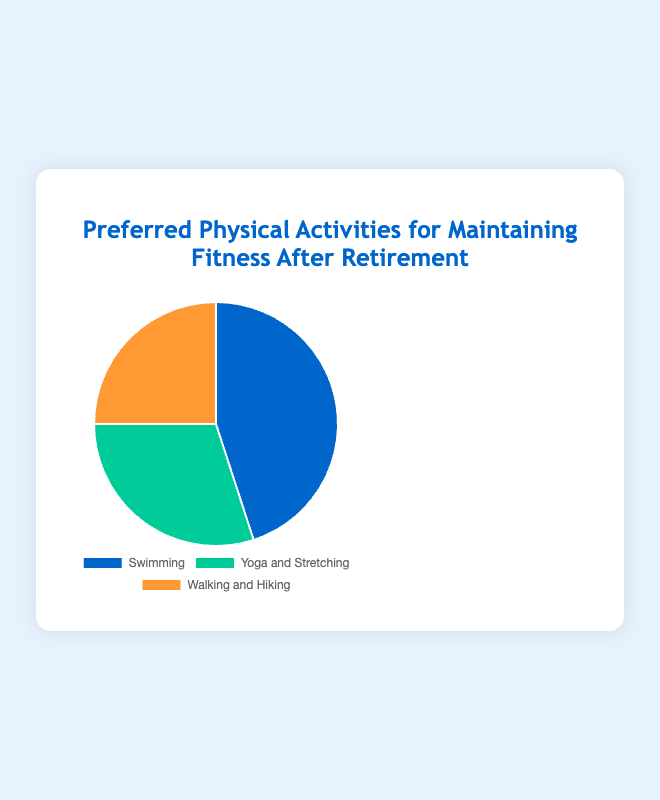What percentage of retirees prefer Yoga and Stretching for maintaining fitness? By looking at the pie chart, we can see that the segment labeled "Yoga and Stretching" makes up 30% of the chart.
Answer: 30% Which activity is preferred by the highest percentage of retirees? The pie chart shows that "Swimming" has the largest segment, indicating that it is preferred by 45% of the retirees.
Answer: Swimming If we combine the percentages of those who prefer Yoga and Stretching with those who prefer Walking and Hiking, what is the total percentage? The percentage for Yoga and Stretching is 30%, and for Walking and Hiking is 25%. Adding these together gives 30% + 25% = 55%.
Answer: 55% Which activity is the least preferred by retirees for maintaining fitness? The pie chart shows that the smallest segment corresponds to "Walking and Hiking," which is 25%.
Answer: Walking and Hiking How much larger is the percentage of retirees who prefer Swimming compared to those who prefer Walking and Hiking? The percentage of retirees who prefer Swimming is 45%, while for Walking and Hiking it is 25%. The difference is 45% - 25% = 20%.
Answer: 20% What is the ratio of retirees who prefer Swimming to those who prefer Yoga and Stretching? The percentage for Swimming is 45%, and for Yoga and Stretching it is 30%. The ratio is 45% : 30%, which simplifies to 3:2.
Answer: 3:2 Which activities combined make up more than two-thirds of the total preferences? Two-thirds of 100% is approximately 66.67%. Adding retirees who prefer Swimming (45%) and Yoga and Stretching (30%) gives 75%, which is more than two-thirds.
Answer: Swimming and Yoga and Stretching What is the fraction of retirees who prefer Walking and Hiking out of the total group? The percentage for Walking and Hiking is 25%. This can be represented as the fraction 25/100, which simplifies to 1/4.
Answer: 1/4 What is the combined percentage of retirees who prefer activities other than Swimming? The activities other than Swimming are Yoga and Stretching (30%) and Walking and Hiking (25%). Adding these together gives 30% + 25% = 55%.
Answer: 55% What color is used to represent Swimming in the pie chart? The segment representing Swimming is colored blue.
Answer: Blue 